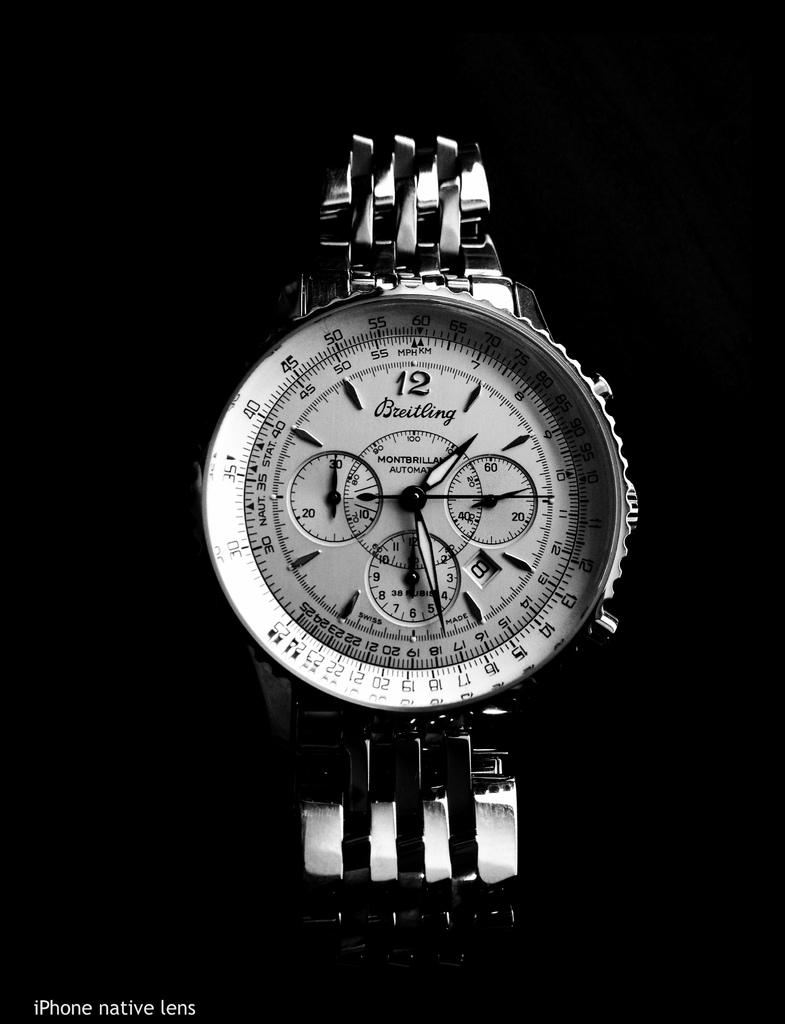Provide a one-sentence caption for the provided image. A Breitling brand of wristwatch with multiple gauges is shown in black and white. 